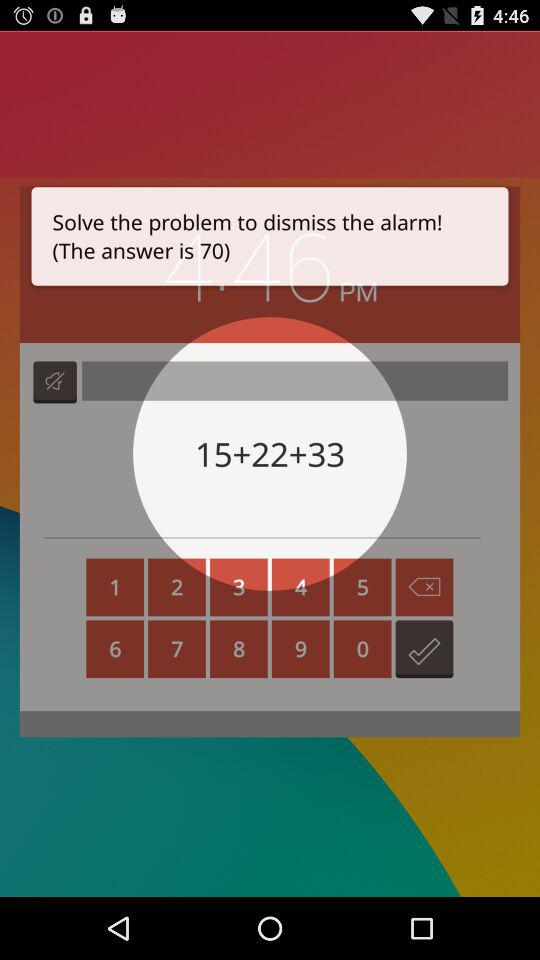What is the total of the three numbers in the equation?
Answer the question using a single word or phrase. 70 